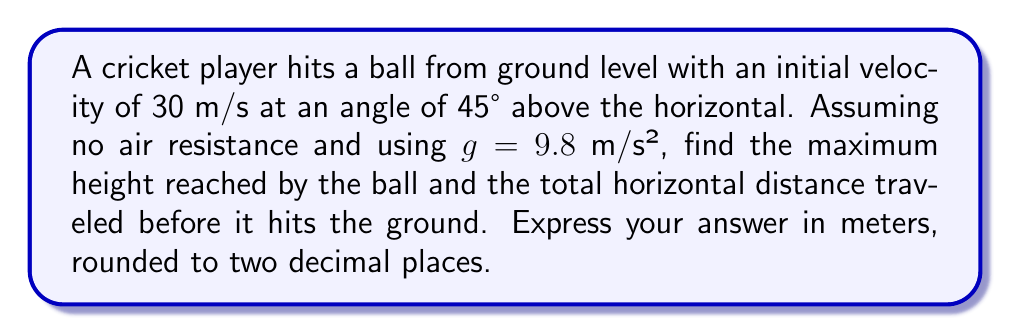Teach me how to tackle this problem. Let's approach this step-by-step using the parabolic equations for projectile motion:

1) The trajectory of the ball can be described by the equation:
   $$y = x \tan \theta - \frac{gx^2}{2v_0^2 \cos^2 \theta}$$
   where $y$ is the vertical position, $x$ is the horizontal position, $\theta$ is the launch angle, $v_0$ is the initial velocity, and $g$ is the acceleration due to gravity.

2) For the maximum height:
   - The vertical component of the initial velocity is $v_0 \sin \theta$
   - The time to reach the maximum height is $t_{max} = \frac{v_0 \sin \theta}{g}$
   - The maximum height is then:
     $$h_{max} = \frac{v_0^2 \sin^2 \theta}{2g}$$

3) Substituting the given values:
   $$h_{max} = \frac{(30)^2 \sin^2 (45°)}{2(9.8)} = \frac{900 * 0.5}{19.6} = 22.96$$

4) For the total horizontal distance:
   - The time of flight is twice the time to reach maximum height:
     $$t_{total} = 2t_{max} = \frac{2v_0 \sin \theta}{g}$$
   - The horizontal distance is then:
     $$R = v_0 \cos \theta * t_{total} = \frac{2v_0^2 \sin \theta \cos \theta}{g}$$

5) Substituting the given values:
   $$R = \frac{2(30)^2 \sin(45°) \cos(45°)}{9.8} = \frac{1800 * 0.5}{9.8} = 91.84$$

Therefore, the maximum height is 22.96 m and the total horizontal distance is 91.84 m.
Answer: Maximum height: 22.96 m, Horizontal distance: 91.84 m 